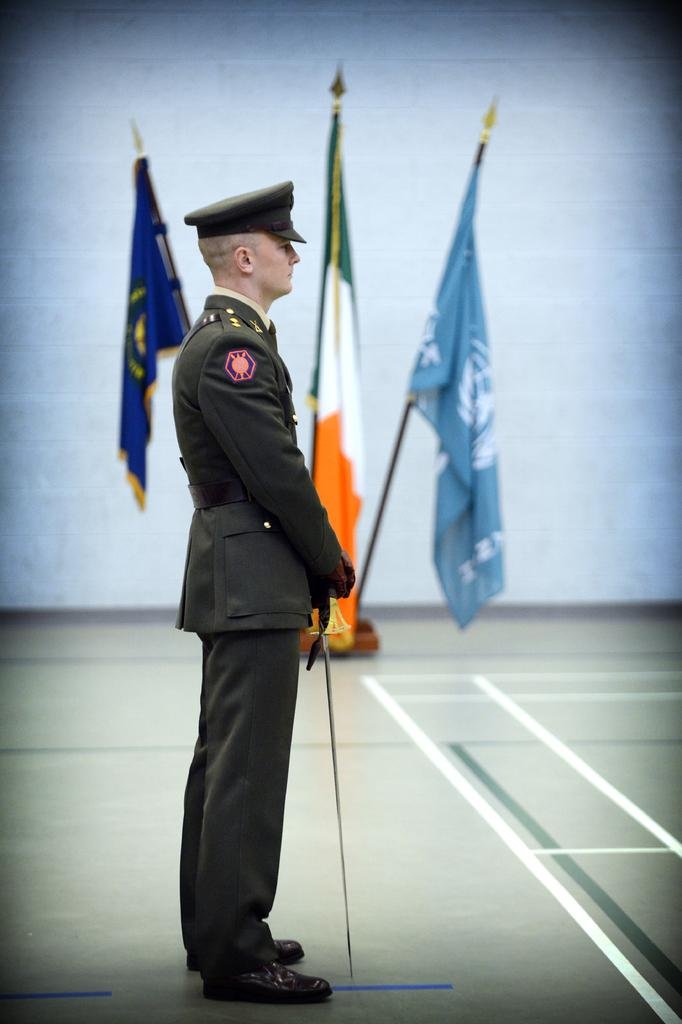What is the main subject of the image? There is a person standing in the image. What else can be seen in the image besides the person? There are three flags and a road in the image. Can you describe the background of the image? There may be a wall in the background of the image. What type of popcorn can be seen falling from the sky in the image? There is no popcorn present in the image, and therefore no such activity can be observed. 